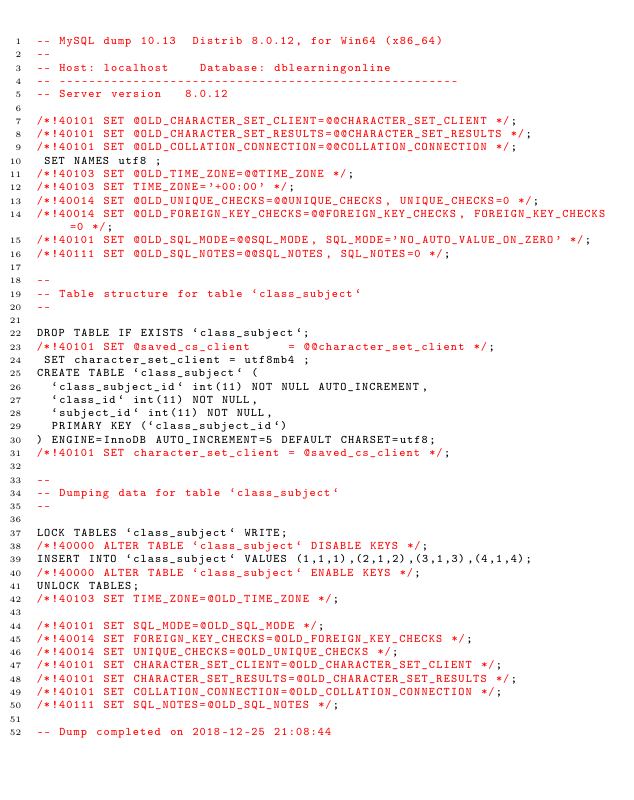Convert code to text. <code><loc_0><loc_0><loc_500><loc_500><_SQL_>-- MySQL dump 10.13  Distrib 8.0.12, for Win64 (x86_64)
--
-- Host: localhost    Database: dblearningonline
-- ------------------------------------------------------
-- Server version	8.0.12

/*!40101 SET @OLD_CHARACTER_SET_CLIENT=@@CHARACTER_SET_CLIENT */;
/*!40101 SET @OLD_CHARACTER_SET_RESULTS=@@CHARACTER_SET_RESULTS */;
/*!40101 SET @OLD_COLLATION_CONNECTION=@@COLLATION_CONNECTION */;
 SET NAMES utf8 ;
/*!40103 SET @OLD_TIME_ZONE=@@TIME_ZONE */;
/*!40103 SET TIME_ZONE='+00:00' */;
/*!40014 SET @OLD_UNIQUE_CHECKS=@@UNIQUE_CHECKS, UNIQUE_CHECKS=0 */;
/*!40014 SET @OLD_FOREIGN_KEY_CHECKS=@@FOREIGN_KEY_CHECKS, FOREIGN_KEY_CHECKS=0 */;
/*!40101 SET @OLD_SQL_MODE=@@SQL_MODE, SQL_MODE='NO_AUTO_VALUE_ON_ZERO' */;
/*!40111 SET @OLD_SQL_NOTES=@@SQL_NOTES, SQL_NOTES=0 */;

--
-- Table structure for table `class_subject`
--

DROP TABLE IF EXISTS `class_subject`;
/*!40101 SET @saved_cs_client     = @@character_set_client */;
 SET character_set_client = utf8mb4 ;
CREATE TABLE `class_subject` (
  `class_subject_id` int(11) NOT NULL AUTO_INCREMENT,
  `class_id` int(11) NOT NULL,
  `subject_id` int(11) NOT NULL,
  PRIMARY KEY (`class_subject_id`)
) ENGINE=InnoDB AUTO_INCREMENT=5 DEFAULT CHARSET=utf8;
/*!40101 SET character_set_client = @saved_cs_client */;

--
-- Dumping data for table `class_subject`
--

LOCK TABLES `class_subject` WRITE;
/*!40000 ALTER TABLE `class_subject` DISABLE KEYS */;
INSERT INTO `class_subject` VALUES (1,1,1),(2,1,2),(3,1,3),(4,1,4);
/*!40000 ALTER TABLE `class_subject` ENABLE KEYS */;
UNLOCK TABLES;
/*!40103 SET TIME_ZONE=@OLD_TIME_ZONE */;

/*!40101 SET SQL_MODE=@OLD_SQL_MODE */;
/*!40014 SET FOREIGN_KEY_CHECKS=@OLD_FOREIGN_KEY_CHECKS */;
/*!40014 SET UNIQUE_CHECKS=@OLD_UNIQUE_CHECKS */;
/*!40101 SET CHARACTER_SET_CLIENT=@OLD_CHARACTER_SET_CLIENT */;
/*!40101 SET CHARACTER_SET_RESULTS=@OLD_CHARACTER_SET_RESULTS */;
/*!40101 SET COLLATION_CONNECTION=@OLD_COLLATION_CONNECTION */;
/*!40111 SET SQL_NOTES=@OLD_SQL_NOTES */;

-- Dump completed on 2018-12-25 21:08:44
</code> 